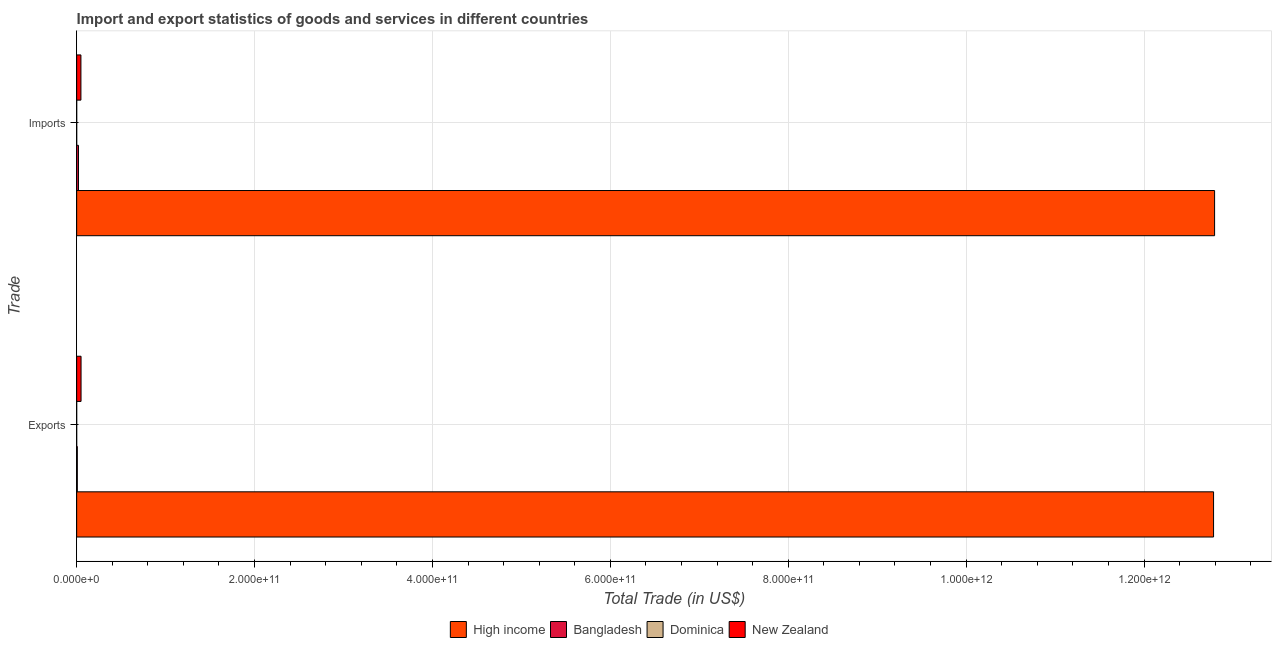How many bars are there on the 2nd tick from the top?
Ensure brevity in your answer.  4. What is the label of the 1st group of bars from the top?
Make the answer very short. Imports. What is the imports of goods and services in Bangladesh?
Keep it short and to the point. 2.06e+09. Across all countries, what is the maximum imports of goods and services?
Make the answer very short. 1.28e+12. Across all countries, what is the minimum imports of goods and services?
Give a very brief answer. 2.93e+07. In which country was the imports of goods and services minimum?
Provide a succinct answer. Dominica. What is the total export of goods and services in the graph?
Keep it short and to the point. 1.28e+12. What is the difference between the export of goods and services in Dominica and that in Bangladesh?
Provide a short and direct response. -7.19e+08. What is the difference between the export of goods and services in Bangladesh and the imports of goods and services in Dominica?
Give a very brief answer. 7.09e+08. What is the average export of goods and services per country?
Provide a short and direct response. 3.21e+11. What is the difference between the imports of goods and services and export of goods and services in Bangladesh?
Offer a very short reply. 1.32e+09. In how many countries, is the imports of goods and services greater than 520000000000 US$?
Your answer should be compact. 1. What is the ratio of the imports of goods and services in Bangladesh to that in High income?
Make the answer very short. 0. In how many countries, is the export of goods and services greater than the average export of goods and services taken over all countries?
Your answer should be very brief. 1. What does the 1st bar from the top in Imports represents?
Your response must be concise. New Zealand. Are all the bars in the graph horizontal?
Keep it short and to the point. Yes. What is the difference between two consecutive major ticks on the X-axis?
Give a very brief answer. 2.00e+11. How many legend labels are there?
Your response must be concise. 4. How are the legend labels stacked?
Your answer should be very brief. Horizontal. What is the title of the graph?
Make the answer very short. Import and export statistics of goods and services in different countries. Does "East Asia (all income levels)" appear as one of the legend labels in the graph?
Your response must be concise. No. What is the label or title of the X-axis?
Offer a terse response. Total Trade (in US$). What is the label or title of the Y-axis?
Make the answer very short. Trade. What is the Total Trade (in US$) in High income in Exports?
Provide a short and direct response. 1.28e+12. What is the Total Trade (in US$) in Bangladesh in Exports?
Give a very brief answer. 7.38e+08. What is the Total Trade (in US$) of Dominica in Exports?
Ensure brevity in your answer.  1.93e+07. What is the Total Trade (in US$) of New Zealand in Exports?
Make the answer very short. 4.94e+09. What is the Total Trade (in US$) in High income in Imports?
Give a very brief answer. 1.28e+12. What is the Total Trade (in US$) in Bangladesh in Imports?
Give a very brief answer. 2.06e+09. What is the Total Trade (in US$) in Dominica in Imports?
Provide a short and direct response. 2.93e+07. What is the Total Trade (in US$) in New Zealand in Imports?
Offer a terse response. 4.80e+09. Across all Trade, what is the maximum Total Trade (in US$) of High income?
Ensure brevity in your answer.  1.28e+12. Across all Trade, what is the maximum Total Trade (in US$) of Bangladesh?
Provide a short and direct response. 2.06e+09. Across all Trade, what is the maximum Total Trade (in US$) in Dominica?
Offer a very short reply. 2.93e+07. Across all Trade, what is the maximum Total Trade (in US$) in New Zealand?
Your answer should be compact. 4.94e+09. Across all Trade, what is the minimum Total Trade (in US$) of High income?
Provide a short and direct response. 1.28e+12. Across all Trade, what is the minimum Total Trade (in US$) in Bangladesh?
Your response must be concise. 7.38e+08. Across all Trade, what is the minimum Total Trade (in US$) of Dominica?
Your answer should be very brief. 1.93e+07. Across all Trade, what is the minimum Total Trade (in US$) of New Zealand?
Provide a succinct answer. 4.80e+09. What is the total Total Trade (in US$) in High income in the graph?
Give a very brief answer. 2.56e+12. What is the total Total Trade (in US$) of Bangladesh in the graph?
Offer a terse response. 2.79e+09. What is the total Total Trade (in US$) in Dominica in the graph?
Make the answer very short. 4.86e+07. What is the total Total Trade (in US$) of New Zealand in the graph?
Provide a succinct answer. 9.74e+09. What is the difference between the Total Trade (in US$) in High income in Exports and that in Imports?
Offer a terse response. -1.17e+09. What is the difference between the Total Trade (in US$) in Bangladesh in Exports and that in Imports?
Offer a very short reply. -1.32e+09. What is the difference between the Total Trade (in US$) of Dominica in Exports and that in Imports?
Ensure brevity in your answer.  -1.00e+07. What is the difference between the Total Trade (in US$) in New Zealand in Exports and that in Imports?
Your answer should be very brief. 1.38e+08. What is the difference between the Total Trade (in US$) of High income in Exports and the Total Trade (in US$) of Bangladesh in Imports?
Provide a succinct answer. 1.28e+12. What is the difference between the Total Trade (in US$) of High income in Exports and the Total Trade (in US$) of Dominica in Imports?
Provide a succinct answer. 1.28e+12. What is the difference between the Total Trade (in US$) of High income in Exports and the Total Trade (in US$) of New Zealand in Imports?
Your answer should be very brief. 1.27e+12. What is the difference between the Total Trade (in US$) of Bangladesh in Exports and the Total Trade (in US$) of Dominica in Imports?
Keep it short and to the point. 7.09e+08. What is the difference between the Total Trade (in US$) in Bangladesh in Exports and the Total Trade (in US$) in New Zealand in Imports?
Your response must be concise. -4.06e+09. What is the difference between the Total Trade (in US$) in Dominica in Exports and the Total Trade (in US$) in New Zealand in Imports?
Provide a short and direct response. -4.78e+09. What is the average Total Trade (in US$) of High income per Trade?
Keep it short and to the point. 1.28e+12. What is the average Total Trade (in US$) in Bangladesh per Trade?
Give a very brief answer. 1.40e+09. What is the average Total Trade (in US$) of Dominica per Trade?
Provide a short and direct response. 2.43e+07. What is the average Total Trade (in US$) in New Zealand per Trade?
Keep it short and to the point. 4.87e+09. What is the difference between the Total Trade (in US$) in High income and Total Trade (in US$) in Bangladesh in Exports?
Offer a very short reply. 1.28e+12. What is the difference between the Total Trade (in US$) of High income and Total Trade (in US$) of Dominica in Exports?
Your response must be concise. 1.28e+12. What is the difference between the Total Trade (in US$) of High income and Total Trade (in US$) of New Zealand in Exports?
Provide a short and direct response. 1.27e+12. What is the difference between the Total Trade (in US$) in Bangladesh and Total Trade (in US$) in Dominica in Exports?
Your answer should be compact. 7.19e+08. What is the difference between the Total Trade (in US$) in Bangladesh and Total Trade (in US$) in New Zealand in Exports?
Provide a succinct answer. -4.20e+09. What is the difference between the Total Trade (in US$) in Dominica and Total Trade (in US$) in New Zealand in Exports?
Make the answer very short. -4.92e+09. What is the difference between the Total Trade (in US$) in High income and Total Trade (in US$) in Bangladesh in Imports?
Your response must be concise. 1.28e+12. What is the difference between the Total Trade (in US$) in High income and Total Trade (in US$) in Dominica in Imports?
Provide a short and direct response. 1.28e+12. What is the difference between the Total Trade (in US$) of High income and Total Trade (in US$) of New Zealand in Imports?
Your response must be concise. 1.27e+12. What is the difference between the Total Trade (in US$) of Bangladesh and Total Trade (in US$) of Dominica in Imports?
Offer a terse response. 2.03e+09. What is the difference between the Total Trade (in US$) in Bangladesh and Total Trade (in US$) in New Zealand in Imports?
Offer a terse response. -2.74e+09. What is the difference between the Total Trade (in US$) of Dominica and Total Trade (in US$) of New Zealand in Imports?
Ensure brevity in your answer.  -4.77e+09. What is the ratio of the Total Trade (in US$) in Bangladesh in Exports to that in Imports?
Offer a very short reply. 0.36. What is the ratio of the Total Trade (in US$) in Dominica in Exports to that in Imports?
Offer a terse response. 0.66. What is the ratio of the Total Trade (in US$) in New Zealand in Exports to that in Imports?
Offer a very short reply. 1.03. What is the difference between the highest and the second highest Total Trade (in US$) in High income?
Provide a succinct answer. 1.17e+09. What is the difference between the highest and the second highest Total Trade (in US$) in Bangladesh?
Your answer should be compact. 1.32e+09. What is the difference between the highest and the second highest Total Trade (in US$) in Dominica?
Keep it short and to the point. 1.00e+07. What is the difference between the highest and the second highest Total Trade (in US$) in New Zealand?
Your answer should be compact. 1.38e+08. What is the difference between the highest and the lowest Total Trade (in US$) in High income?
Your answer should be compact. 1.17e+09. What is the difference between the highest and the lowest Total Trade (in US$) in Bangladesh?
Offer a very short reply. 1.32e+09. What is the difference between the highest and the lowest Total Trade (in US$) of Dominica?
Offer a terse response. 1.00e+07. What is the difference between the highest and the lowest Total Trade (in US$) in New Zealand?
Provide a succinct answer. 1.38e+08. 